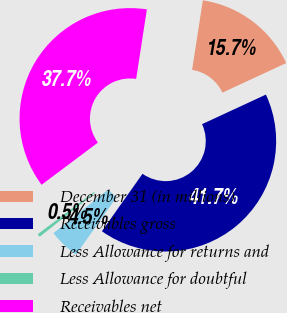<chart> <loc_0><loc_0><loc_500><loc_500><pie_chart><fcel>December 31 (in millions)<fcel>Receivables gross<fcel>Less Allowance for returns and<fcel>Less Allowance for doubtful<fcel>Receivables net<nl><fcel>15.66%<fcel>41.7%<fcel>4.51%<fcel>0.47%<fcel>37.66%<nl></chart> 